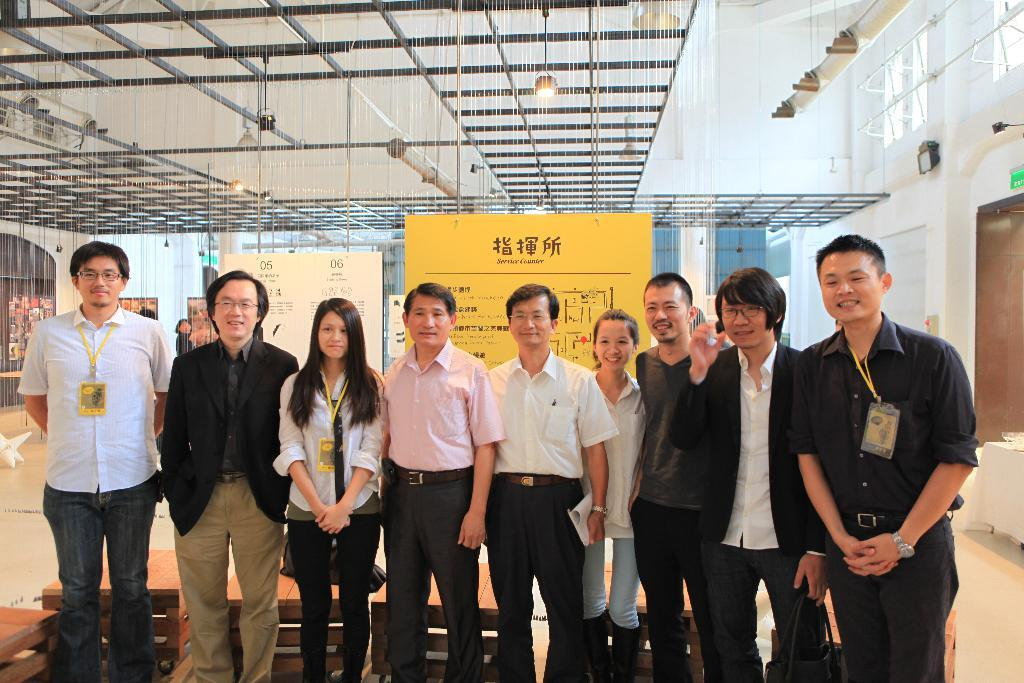What are the people in the image doing? The people in the image are taking pictures. What might be the purpose of the boards visible in the background? The boards in the background might be used for displaying information or as a backdrop for the pictures being taken. What type of arithmetic problem is being solved on the face of one of the people in the image? There is no arithmetic problem being solved on the face of any person in the image. What boundary is visible in the image? There is no boundary visible in the image; it features people taking pictures and boards in the background. 